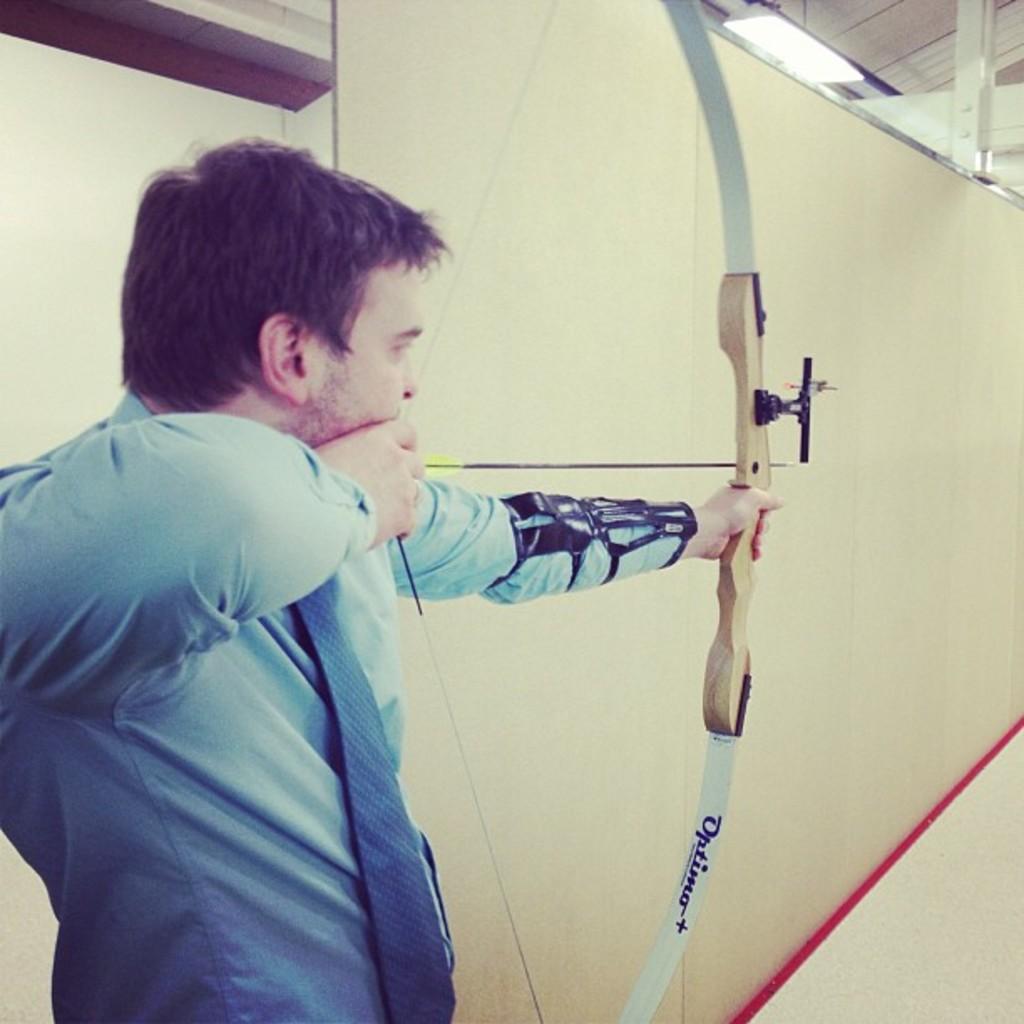How would you summarize this image in a sentence or two? This image consists of a man, who is bowling an arrow. He is wearing a blue dress. 